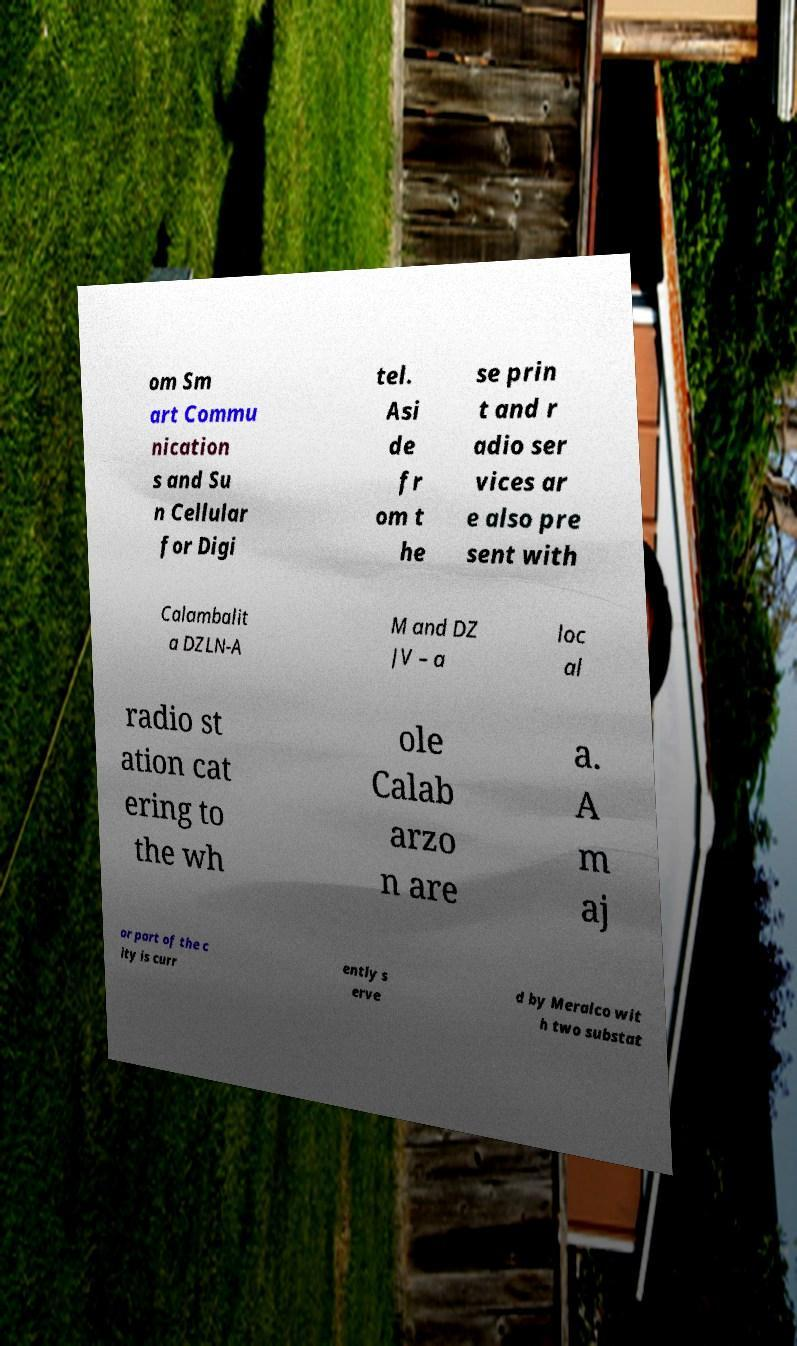Can you accurately transcribe the text from the provided image for me? om Sm art Commu nication s and Su n Cellular for Digi tel. Asi de fr om t he se prin t and r adio ser vices ar e also pre sent with Calambalit a DZLN-A M and DZ JV – a loc al radio st ation cat ering to the wh ole Calab arzo n are a. A m aj or part of the c ity is curr ently s erve d by Meralco wit h two substat 